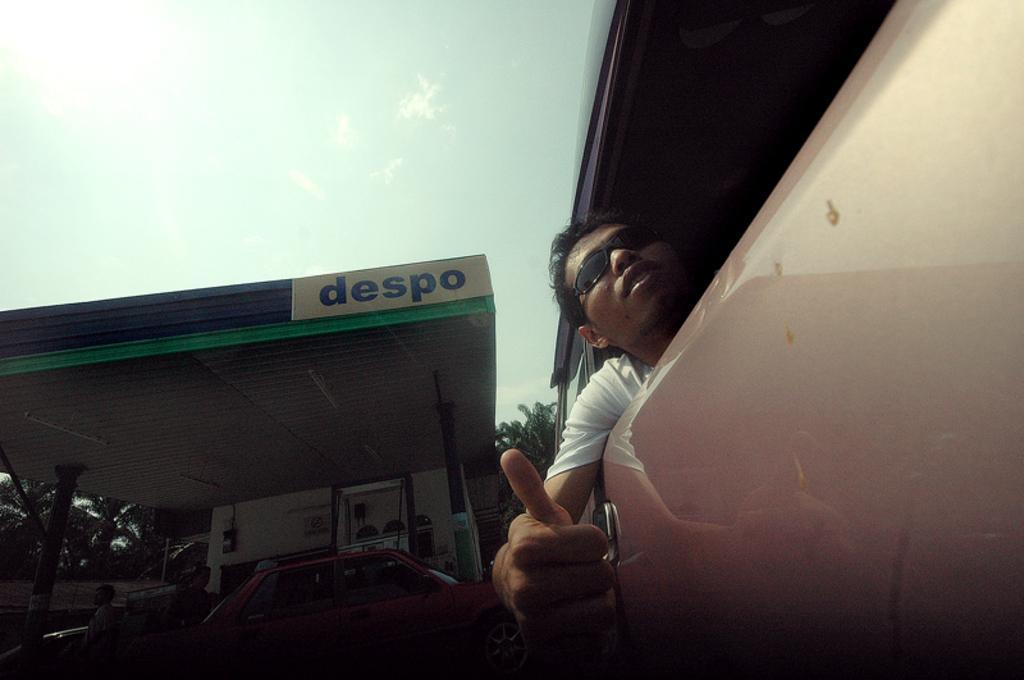Please provide a concise description of this image. On the right side of the image, we can see one vehicle. In the vehicle, we can see one person sitting and he is wearing glasses. In the background, we can see the sky, clouds, trees, one petrol bunk, one building, pillars, one vehicle, banners, fence, few people are standing and a few other objects. 